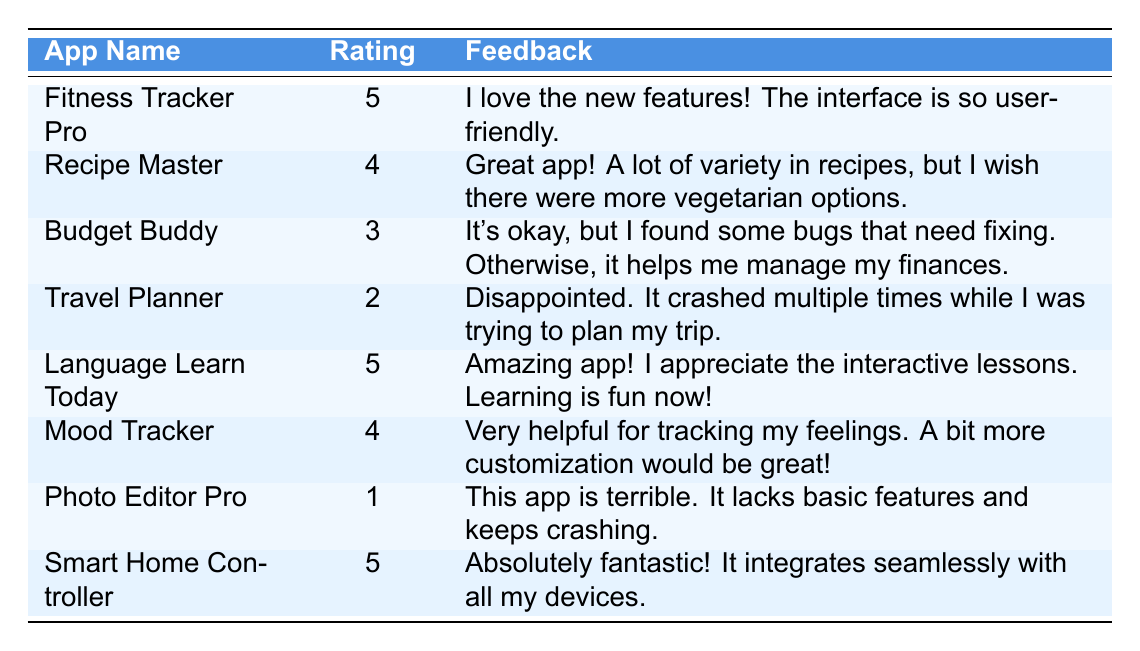What is the user rating for the app "Mood Tracker"? According to the table, the user rating for "Mood Tracker" is listed directly in the second column next to the app name, which shows a rating of 4.
Answer: 4 What feedback did users give for "Recipe Master"? The table reveals that the feedback for "Recipe Master" is provided in the third column, where users mentioned enjoying the variety of recipes but expressed a desire for more vegetarian options.
Answer: Great app! A lot of variety in recipes, but I wish there were more vegetarian options Is there any app with a user rating of 1? Looking through the table, "Photo Editor Pro" is the only app that has a user rating of 1. Thus, the answer is yes.
Answer: Yes What is the average user rating of all the apps listed in the table? To find the average user rating, we first sum all the ratings: (5 + 4 + 3 + 2 + 5 + 4 + 1 + 5) = 29. There are 8 apps, therefore the average is 29/8 which equals 3.625.
Answer: 3.625 How many apps received a user rating of 5? By reviewing the table, we can see that "Fitness Tracker Pro," "Language Learn Today," and "Smart Home Controller" all have a rating of 5. Counting these entries gives us a total of 3 apps.
Answer: 3 Which app received the lowest rating and what was the feedback? The app with the lowest rating is "Photo Editor Pro," which received a rating of 1. The corresponding feedback indicates that users found it terrible, lacking basic features and experiencing crashes.
Answer: Photo Editor Pro; This app is terrible. It lacks basic features and keeps crashing Did "Travel Planner" receive more positive feedback than "Budget Buddy"? Analyzing the user ratings shows that "Travel Planner" received a rating of 2, while "Budget Buddy" received a 3. Since 3 is greater than 2, "Budget Buddy" indeed received more positive feedback.
Answer: Yes What do the majority of users appreciate about "Language Learn Today"? In the feedback for "Language Learn Today," users highlighted appreciating the interactive lessons, which enhanced their learning experience. Thus, the majority appreciate its engagement feature.
Answer: Interactive lessons 